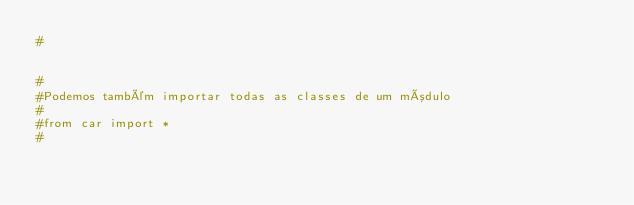Convert code to text. <code><loc_0><loc_0><loc_500><loc_500><_Python_>#


#
#Podemos também importar todas as classes de um módulo
#
#from car import *
#</code> 